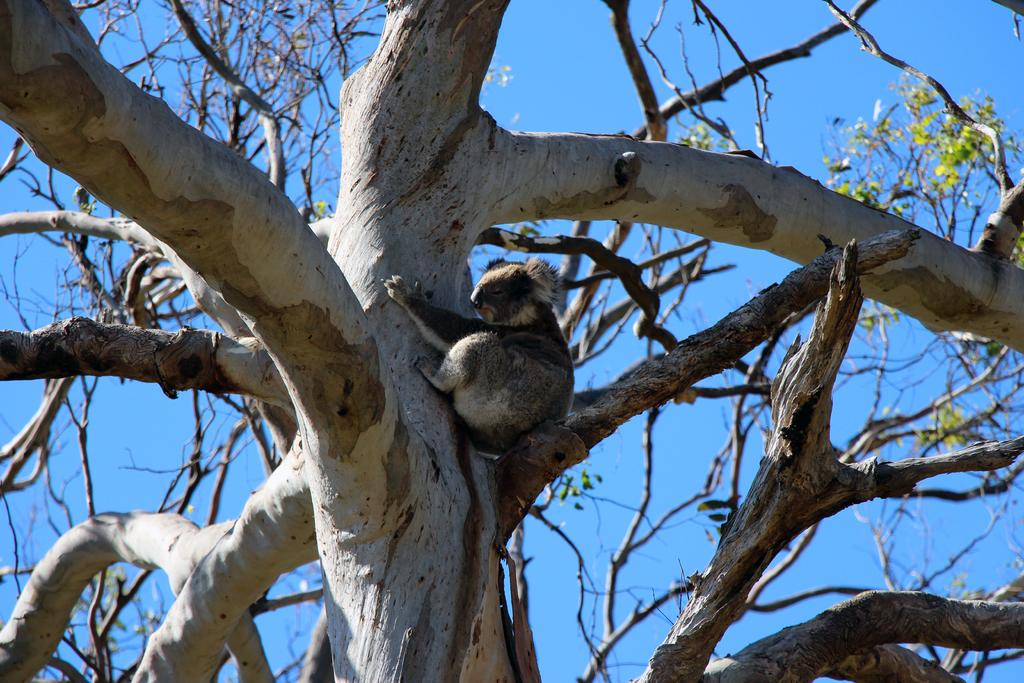What type of animal can be seen in the image? There is an animal in the image. Where is the animal located? The animal is sitting on a tree. What can be seen in the background of the image? The sky is visible in the background of the image. How many legs does the animal have in the image? The provided facts do not mention the number of legs the animal has, so it cannot be determined from the image. 